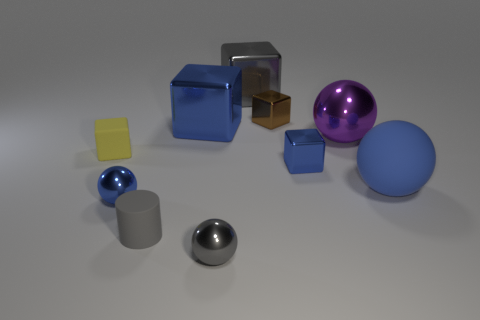Subtract all balls. How many objects are left? 6 Add 6 balls. How many balls are left? 10 Add 2 yellow matte cubes. How many yellow matte cubes exist? 3 Subtract 0 cyan blocks. How many objects are left? 10 Subtract all red metallic things. Subtract all gray cylinders. How many objects are left? 9 